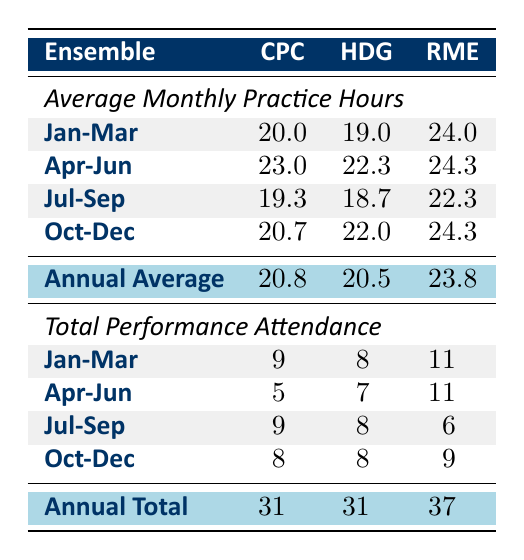What was the total performance attendance for the Rhythm Masters Ensemble in the first quarter? The first quarter consists of January, February, and March. The performance attendance for these months for the Rhythm Masters Ensemble is 4 (January) + 4 (February) + 3 (March) = 11.
Answer: 11 Which ensemble had the highest average monthly practice hours during the third quarter? The third quarter includes July, August, and September. The average monthly practice hours are calculated as follows: City Percussion Collective: (15 + 23 + 20)/3 = 19.3, Harmony Drummers Guild: (16 + 21 + 19)/3 = 18.7, Rhythm Masters Ensemble: (18 + 24 + 25)/3 = 22.3. The highest average is 22.3 for Rhythm Masters Ensemble.
Answer: Rhythm Masters Ensemble Is it true that the City Percussion Collective had more total performance attendance than the Harmony Drummers Guild? Total attendance for City Percussion Collective is 31 and for Harmony Drummers Guild is also 31. Therefore, the statement is false as they are equal.
Answer: False What is the average number of performance attendances for the City Percussion Collective in the fourth quarter? The fourth quarter includes October, November, and December. The total performances for those months are 3 (October) + 2 (November) + 3 (December) = 8. The average is 8/3 = approximately 2.67.
Answer: Approximately 2.7 How many more practice hours did Rhythm Masters Ensemble have in May compared to Harmony Drummers Guild? In May, Rhythm Masters Ensemble practiced for 27 hours and Harmony Drummers Guild practiced for 22 hours. The difference is 27 - 22 = 5.
Answer: 5 